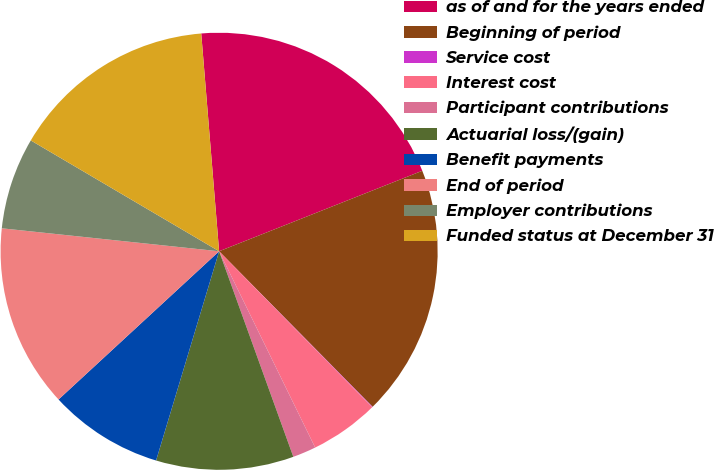Convert chart to OTSL. <chart><loc_0><loc_0><loc_500><loc_500><pie_chart><fcel>as of and for the years ended<fcel>Beginning of period<fcel>Service cost<fcel>Interest cost<fcel>Participant contributions<fcel>Actuarial loss/(gain)<fcel>Benefit payments<fcel>End of period<fcel>Employer contributions<fcel>Funded status at December 31<nl><fcel>20.3%<fcel>18.61%<fcel>0.04%<fcel>5.11%<fcel>1.73%<fcel>10.17%<fcel>8.48%<fcel>13.54%<fcel>6.79%<fcel>15.23%<nl></chart> 